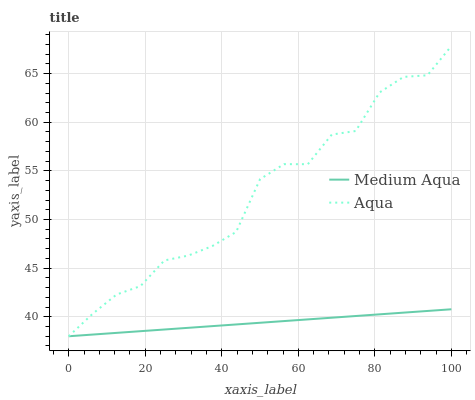Does Medium Aqua have the minimum area under the curve?
Answer yes or no. Yes. Does Aqua have the maximum area under the curve?
Answer yes or no. Yes. Does Medium Aqua have the maximum area under the curve?
Answer yes or no. No. Is Medium Aqua the smoothest?
Answer yes or no. Yes. Is Aqua the roughest?
Answer yes or no. Yes. Is Medium Aqua the roughest?
Answer yes or no. No. Does Aqua have the lowest value?
Answer yes or no. Yes. Does Aqua have the highest value?
Answer yes or no. Yes. Does Medium Aqua have the highest value?
Answer yes or no. No. Does Medium Aqua intersect Aqua?
Answer yes or no. Yes. Is Medium Aqua less than Aqua?
Answer yes or no. No. Is Medium Aqua greater than Aqua?
Answer yes or no. No. 